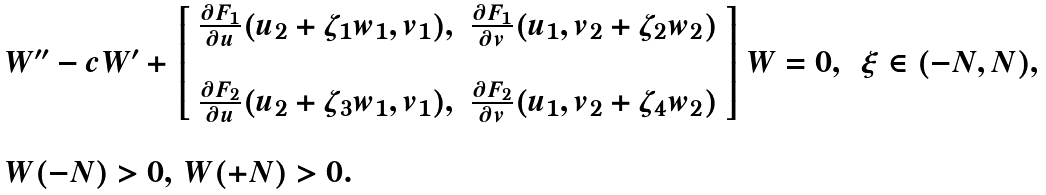<formula> <loc_0><loc_0><loc_500><loc_500>\begin{array} { l l } W ^ { \prime \prime } - c W ^ { \prime } + \left [ \begin{array} { c c } \frac { \partial F _ { 1 } } { \partial u } ( u _ { 2 } + \zeta _ { 1 } w _ { 1 } , v _ { 1 } ) , & \frac { \partial F _ { 1 } } { \partial v } ( u _ { 1 } , v _ { 2 } + \zeta _ { 2 } w _ { 2 } ) \\ \\ \frac { \partial F _ { 2 } } { \partial u } ( u _ { 2 } + \zeta _ { 3 } w _ { 1 } , v _ { 1 } ) , & \frac { \partial F _ { 2 } } { \partial v } ( u _ { 1 } , v _ { 2 } + \zeta _ { 4 } w _ { 2 } ) \end{array} \right ] W = 0 , \, & \xi \in ( - N , N ) , \\ \\ W ( - N ) > 0 , \, W ( + N ) > 0 . \end{array}</formula> 